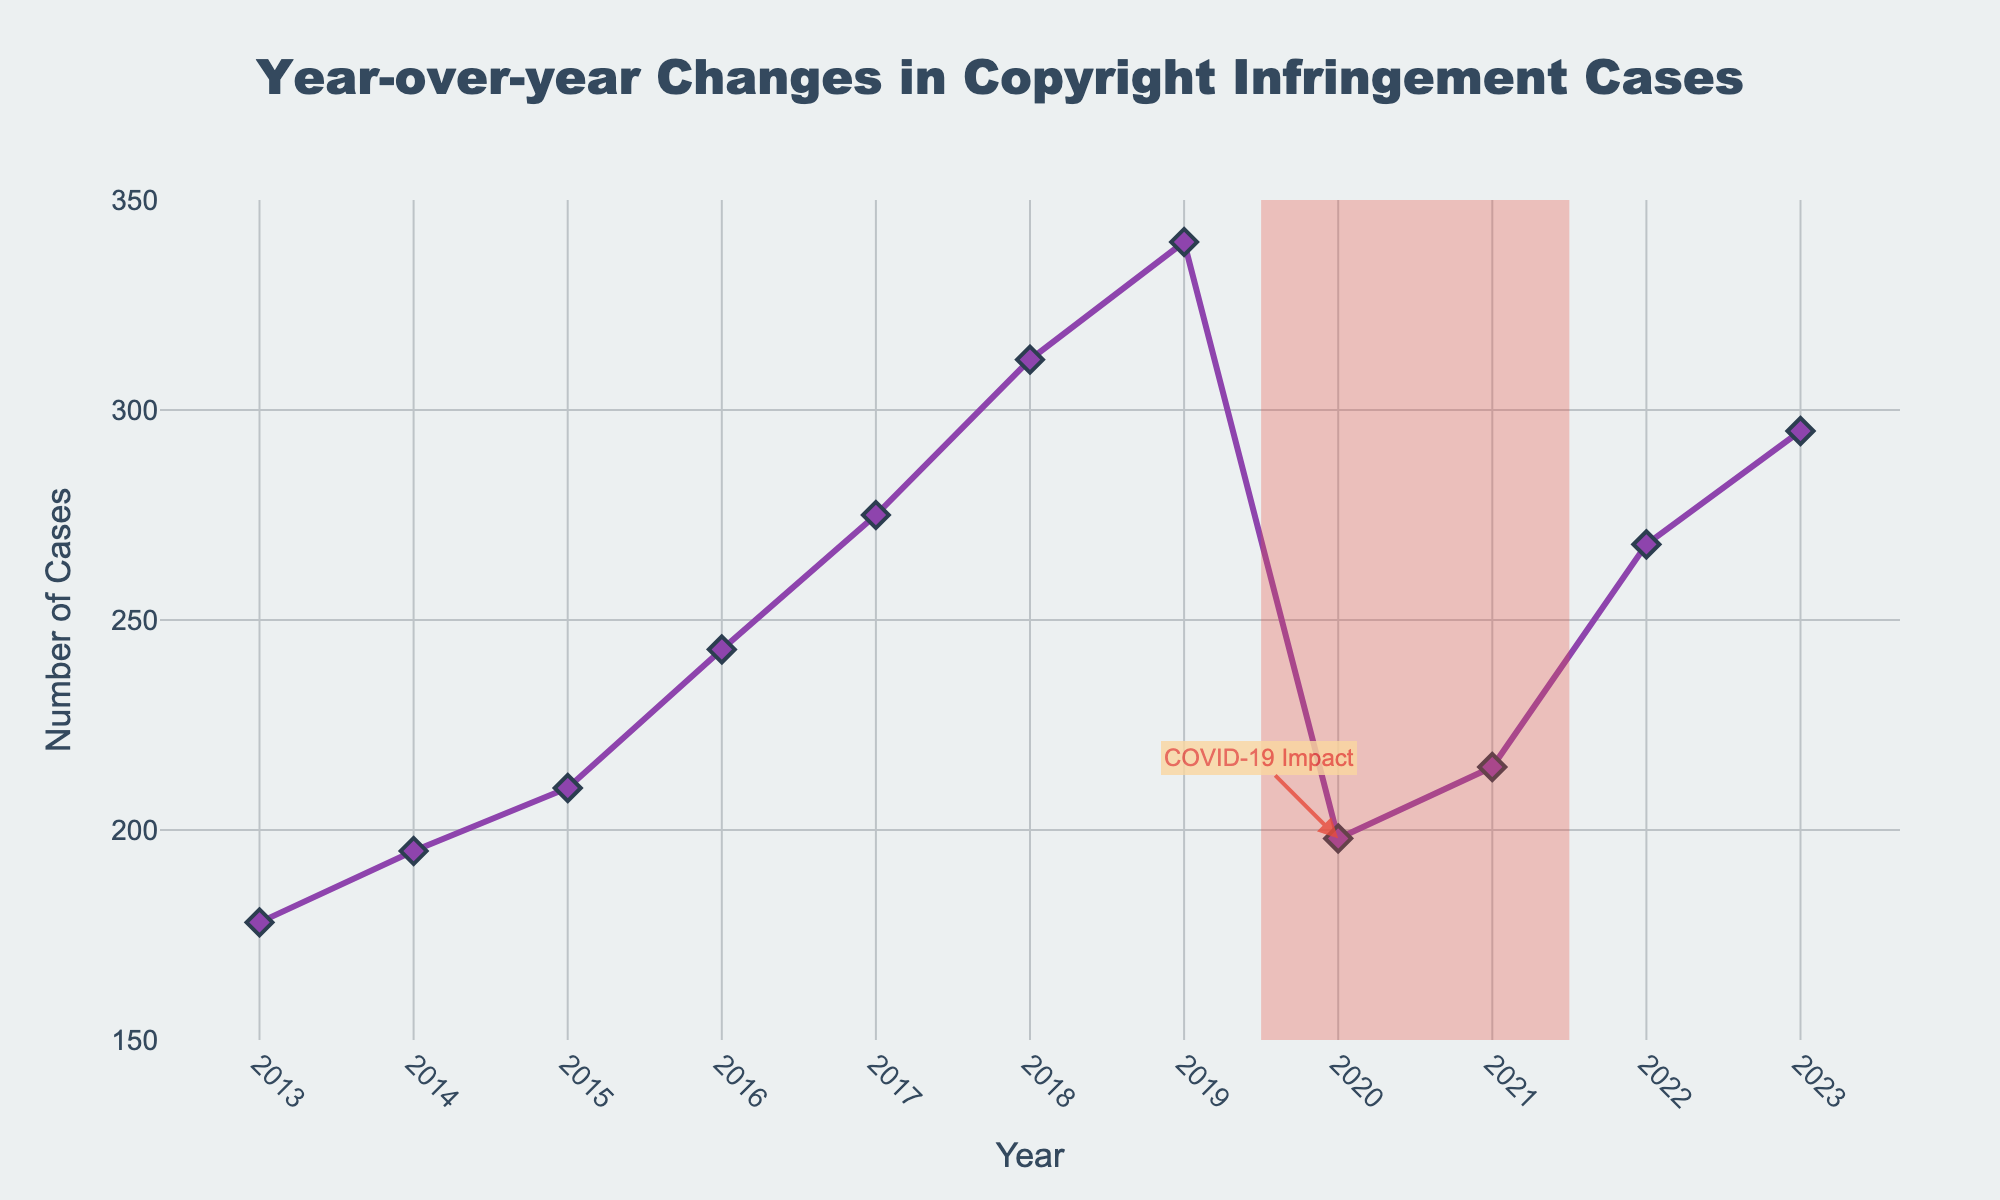what is the trend in copyright infringement cases from 2013 to 2023? The figure shows an upward trend in copyright infringement cases from 2013, starting at 178 cases and peaking in 2019 at 340 cases, and then declining in 2020 to 198 cases, followed by an increase up to 295 cases in 2023
Answer: upward trend from 2013 to 2019, decline in 2020, increase after 2020 how did the number of copyright infringement cases change from 2019 to 2020? The number of cases decreased significantly from 340 in 2019 to 198 in 2020
Answer: decreased significantly when did the number of copyright infringement cases reach its lowest point? The lowest point for copyright infringement cases was in 2013 with 178 cases
Answer: 2013 what is the difference in the number of copyright infringement cases between 2016 and 2022? The number of cases in 2022 was 268 and in 2016 it was 243. The difference is 268 - 243 = 25 cases
Answer: 25 cases which year had the highest number of copyright infringement cases? The year with the highest number of copyright infringement cases is 2019 with 340 cases
Answer: 2019 how did the COVID-19 impact in 2020 affect copyright infringement cases? The figure highlights the COVID-19 period (2019.5-2021.5) with a shaded rectangle and a text annotation at 2020 showing a noticeable drop in cases from 340 in 2019 to 198 in 2020
Answer: noticeable drop in cases from 2019 to 2020 compare the number of copyright infringement cases in 2013 and 2023? In 2013, there were 178 cases, while in 2023, there were 295 cases. The number of cases increased from 178 to 295
Answer: increased from 178 to 295 what is the average number of copyright infringement cases from 2013 to 2023? Summing the cases from 2013 to 2023 gives a total of 2716 cases. There are 11 years, so the average is 2716 / 11 ≈ 247 cases per year
Answer: 247 cases per year what visual elements are used to highlight the COVID-19 period in the chart? The visual elements include a shaded rectangle over the years 2019.5 to 2021.5 and a text annotation at 2020 with the label "COVID-19 Impact"
Answer: shaded rectangle and text annotation 